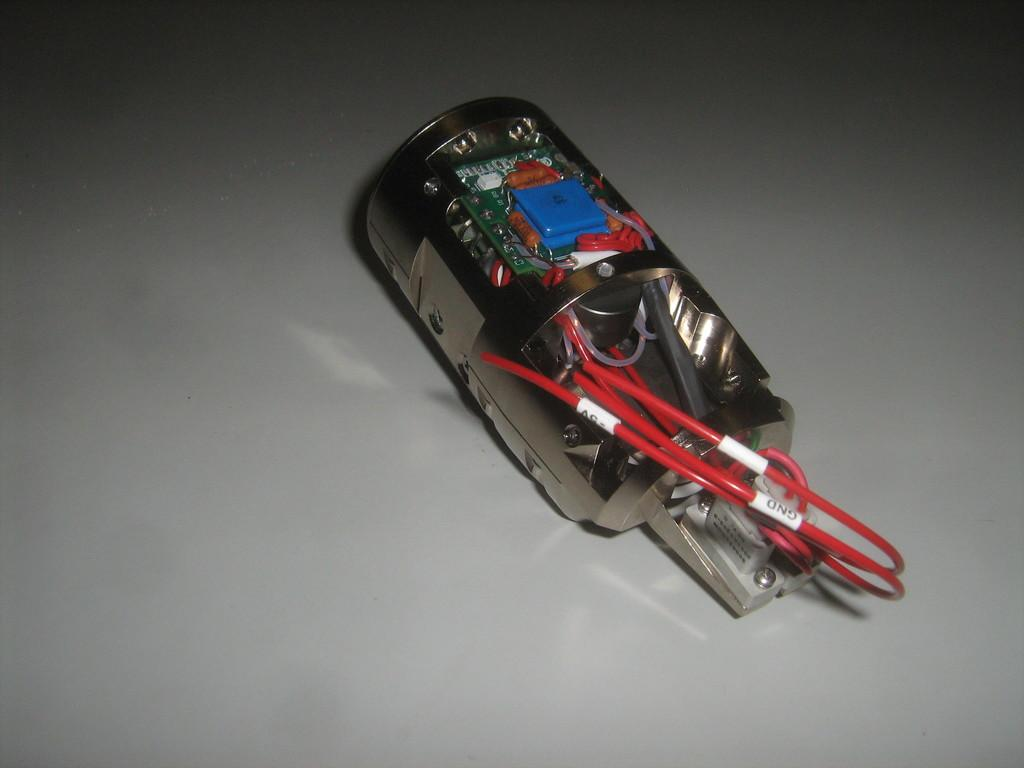What is the main subject in the image? There is a device in the image. What can be observed about the wires of the device? The device has red color wires. How is the device positioned in the image? The device is placed on a platform. How many cherries are placed on top of the device in the image? There are no cherries present in the image. What is the height of the device in relation to the platform? The provided facts do not give information about the height of the device in relation to the platform. 